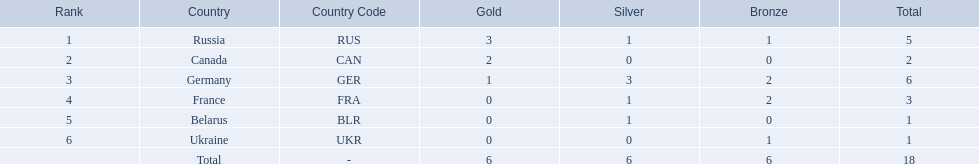Which countries competed in the 1995 biathlon? Russia (RUS), Canada (CAN), Germany (GER), France (FRA), Belarus (BLR), Ukraine (UKR). How many medals in total did they win? 5, 2, 6, 3, 1, 1. And which country had the most? Germany (GER). 